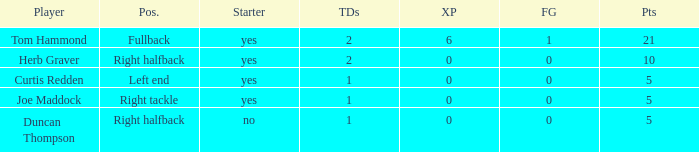Write the full table. {'header': ['Player', 'Pos.', 'Starter', 'TDs', 'XP', 'FG', 'Pts'], 'rows': [['Tom Hammond', 'Fullback', 'yes', '2', '6', '1', '21'], ['Herb Graver', 'Right halfback', 'yes', '2', '0', '0', '10'], ['Curtis Redden', 'Left end', 'yes', '1', '0', '0', '5'], ['Joe Maddock', 'Right tackle', 'yes', '1', '0', '0', '5'], ['Duncan Thompson', 'Right halfback', 'no', '1', '0', '0', '5']]} Name the starter for position being left end Yes. 